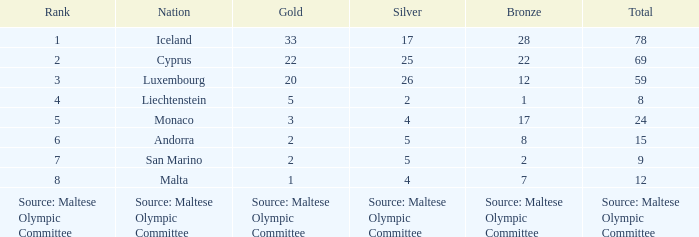What is the complete medal sum for the nation that holds 5 gold medals? 8.0. Could you parse the entire table? {'header': ['Rank', 'Nation', 'Gold', 'Silver', 'Bronze', 'Total'], 'rows': [['1', 'Iceland', '33', '17', '28', '78'], ['2', 'Cyprus', '22', '25', '22', '69'], ['3', 'Luxembourg', '20', '26', '12', '59'], ['4', 'Liechtenstein', '5', '2', '1', '8'], ['5', 'Monaco', '3', '4', '17', '24'], ['6', 'Andorra', '2', '5', '8', '15'], ['7', 'San Marino', '2', '5', '2', '9'], ['8', 'Malta', '1', '4', '7', '12'], ['Source: Maltese Olympic Committee', 'Source: Maltese Olympic Committee', 'Source: Maltese Olympic Committee', 'Source: Maltese Olympic Committee', 'Source: Maltese Olympic Committee', 'Source: Maltese Olympic Committee']]} 